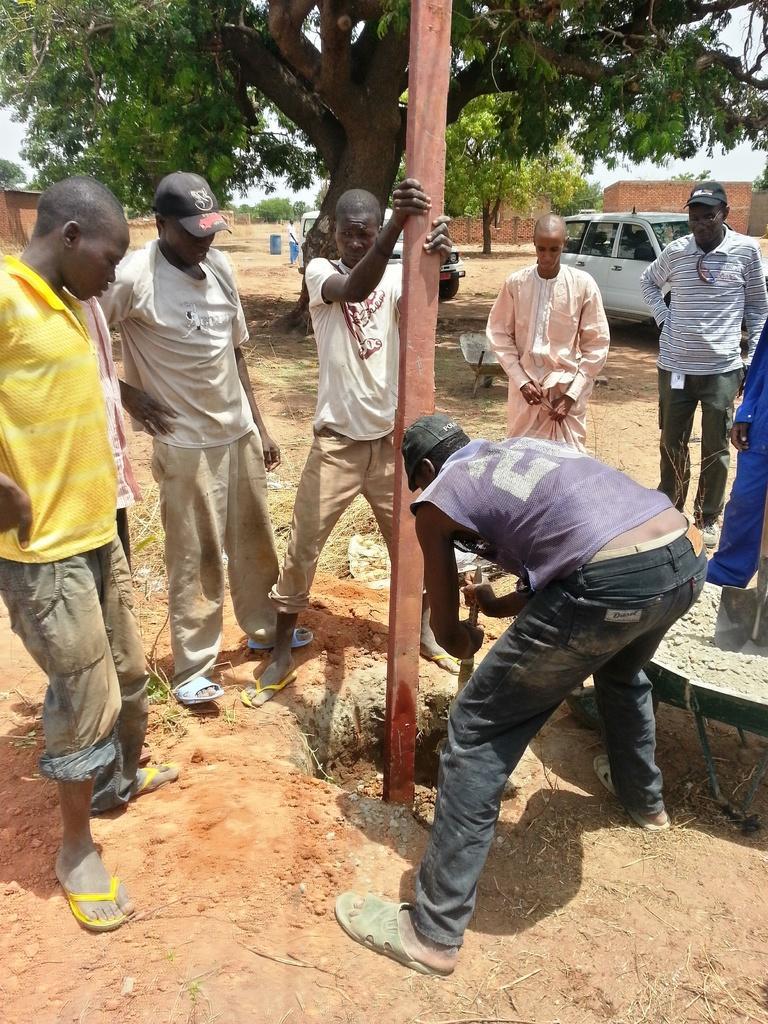How would you summarize this image in a sentence or two? In this image there are two people holding and planting a wooden block in the earth, around them there are a few people standing, in the background of the image there are cars parked, trees and brick houses. 